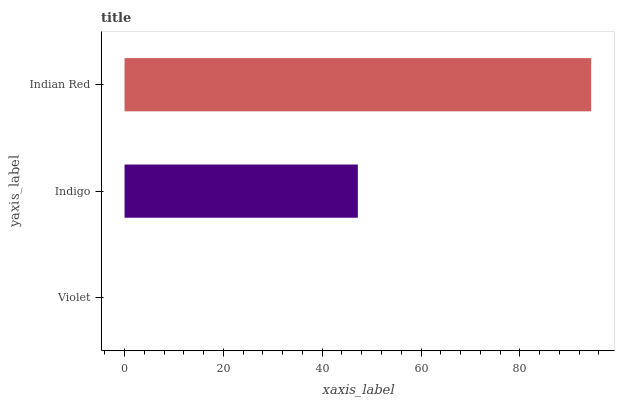Is Violet the minimum?
Answer yes or no. Yes. Is Indian Red the maximum?
Answer yes or no. Yes. Is Indigo the minimum?
Answer yes or no. No. Is Indigo the maximum?
Answer yes or no. No. Is Indigo greater than Violet?
Answer yes or no. Yes. Is Violet less than Indigo?
Answer yes or no. Yes. Is Violet greater than Indigo?
Answer yes or no. No. Is Indigo less than Violet?
Answer yes or no. No. Is Indigo the high median?
Answer yes or no. Yes. Is Indigo the low median?
Answer yes or no. Yes. Is Violet the high median?
Answer yes or no. No. Is Violet the low median?
Answer yes or no. No. 